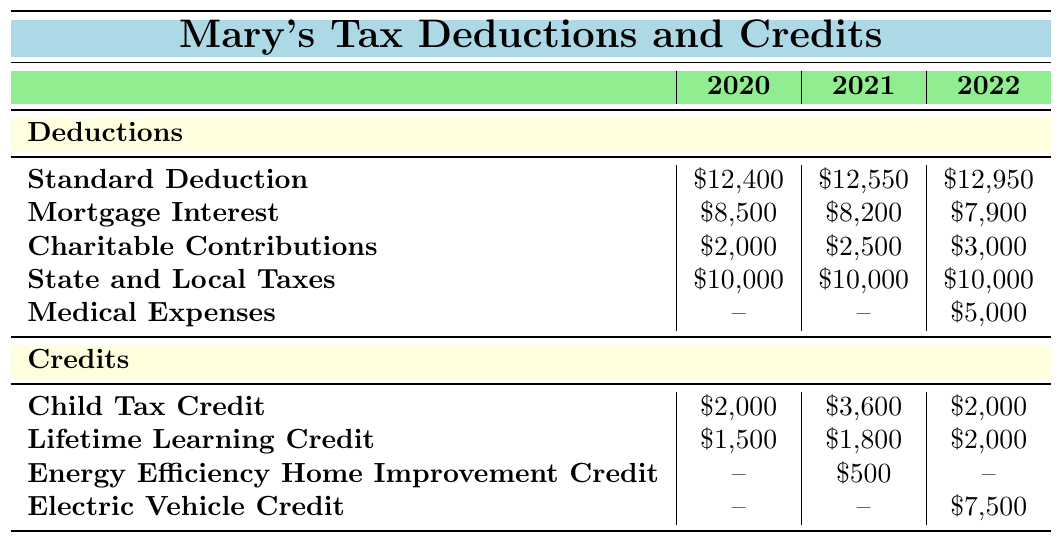What was the total amount of deductions in 2021? In 2021, we need to add up all the deductions: Standard Deduction (\$12,550) + Mortgage Interest (\$8,200) + Charitable Contributions (\$2,500) + State and Local Taxes (\$10,000). Thus, the total is \$12,550 + \$8,200 + \$2,500 + \$10,000 = \$33,250.
Answer: \$33,250 Which year had the highest amount of Charitable Contributions? To find the year with the highest Charitable Contributions, we compare the values: in 2020 it was \$2,000, in 2021 it was \$2,500, and in 2022 it was \$3,000. Hence, 2022 had the highest amount of Charitable Contributions.
Answer: 2022 Did Mary receive the Energy Efficiency Home Improvement Credit in 2020? Looking at the credits listed for 2020, the Energy Efficiency Home Improvement Credit is not present, which indicates that she did not receive it that year.
Answer: No What was the increase in the Child Tax Credit from 2020 to 2021? To find the increase in the Child Tax Credit between 2020 (\$2,000) and 2021 (\$3,600), we calculate the difference: \$3,600 - \$2,000 = \$1,600.
Answer: \$1,600 What is the overall trend in Medical Expenses from 2020 to 2022? In 2020, Medical Expenses were not considered (indicated by --), in 2021, they were still not applicable (also indicated by --), but in 2022, there was a deduction of \$5,000. Thus, there was an increase from being not applicable to \$5,000 in 2022.
Answer: Increase from not applicable to \$5,000 What was the total amount of credits Mary received in 2022? To find the total amount of credits in 2022, we need to add them up: Child Tax Credit (\$2,000) + Lifetime Learning Credit (\$2,000) + Electric Vehicle Credit (\$7,500). Therefore, the total is \$2,000 + \$2,000 + \$7,500 = \$11,500.
Answer: \$11,500 In which year were the deductions for State and Local Taxes consistent, and what was the amount? The deductions for State and Local Taxes were consistent in all three years (2020, 2021, and 2022), with the amount remaining at \$10,000 each year.
Answer: \$10,000 in all years What was the difference in the total deductions between 2020 and 2022? First, we calculate the deductions for each year: total for 2020 = \$12,400 + \$8,500 + \$2,000 + \$10,000 = \$32,900; total for 2022 = \$12,950 + \$7,900 + \$3,000 + \$10,000 + \$5,000 = \$38,850. Then, we find the difference: \$38,850 - \$32,900 = \$5,950.
Answer: \$5,950 Which credit was not available in 2020 but appeared in 2021? In reviewing the credits, the Energy Efficiency Home Improvement Credit was introduced in 2021 with an amount of \$500 while it was not available in 2020.
Answer: Energy Efficiency Home Improvement Credit 